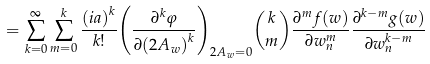<formula> <loc_0><loc_0><loc_500><loc_500>= \sum _ { k = 0 } ^ { \infty } \sum _ { m = 0 } ^ { k } \frac { { ( i a ) } ^ { k } } { k ! } { \left ( \frac { \partial ^ { k } \varphi } { \partial { ( 2 A _ { w } ) } ^ { k } } \right ) } _ { 2 A _ { w } = 0 } { k \choose m } \frac { \partial ^ { m } f ( w ) } { \partial w _ { n } ^ { m } } \frac { \partial ^ { k - m } g ( w ) } { \partial w _ { n } ^ { k - m } }</formula> 